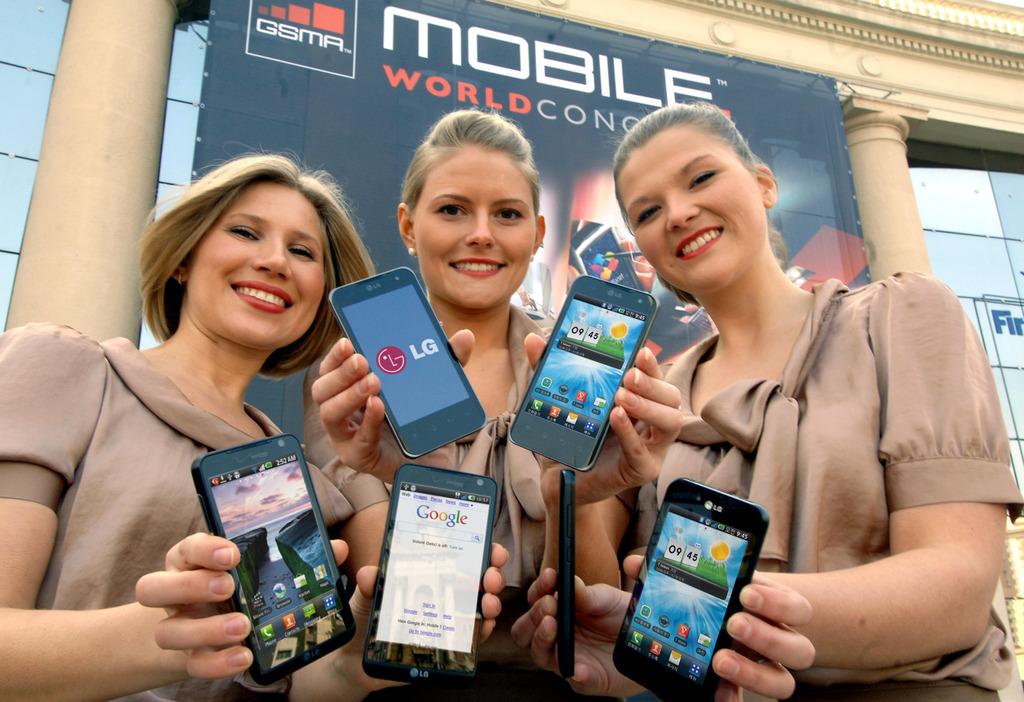What type of phone is it?
Your answer should be very brief. Lg. What webpage is the bottom middle phone displaying?
Offer a very short reply. Google. 